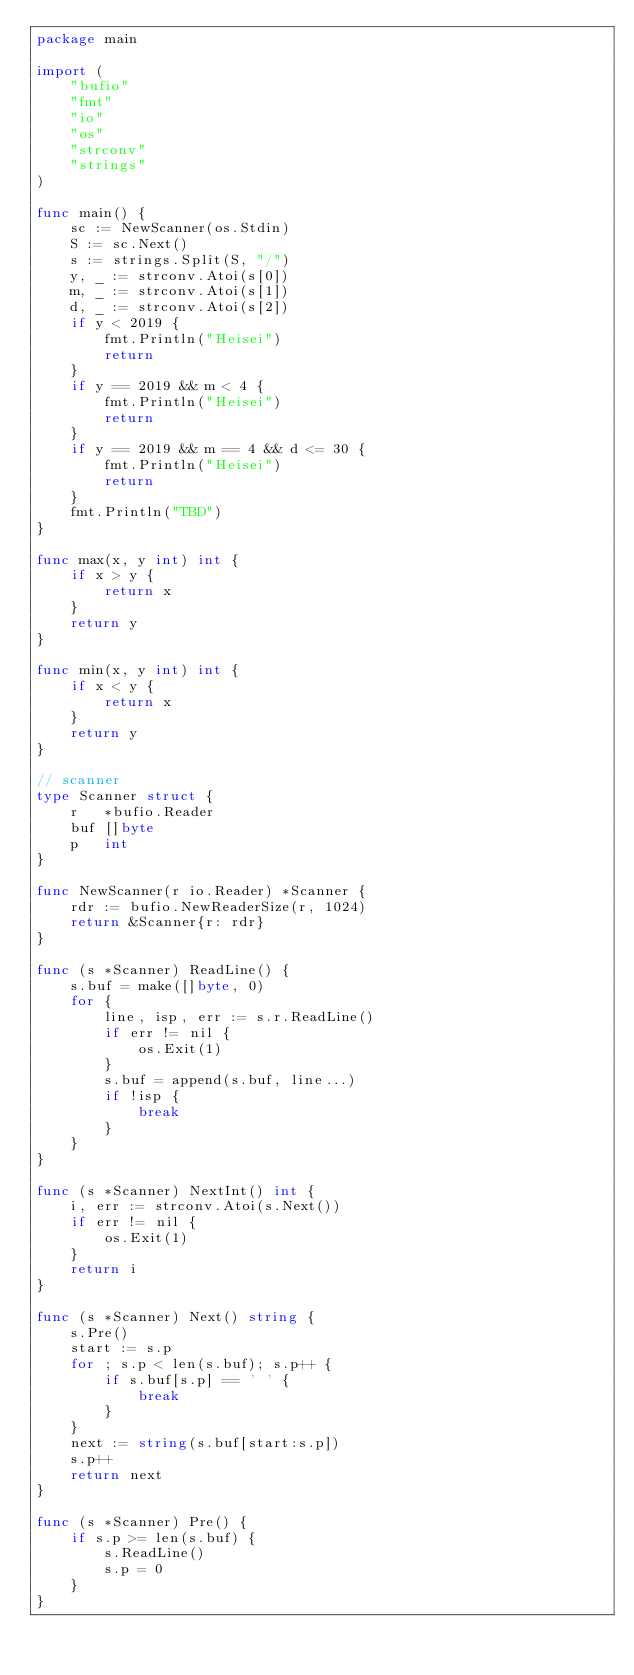Convert code to text. <code><loc_0><loc_0><loc_500><loc_500><_Go_>package main

import (
	"bufio"
	"fmt"
	"io"
	"os"
	"strconv"
	"strings"
)

func main() {
	sc := NewScanner(os.Stdin)
	S := sc.Next()
	s := strings.Split(S, "/")
	y, _ := strconv.Atoi(s[0])
	m, _ := strconv.Atoi(s[1])
	d, _ := strconv.Atoi(s[2])
	if y < 2019 {
		fmt.Println("Heisei")
		return
	}
	if y == 2019 && m < 4 {
		fmt.Println("Heisei")
		return
	}
	if y == 2019 && m == 4 && d <= 30 {
		fmt.Println("Heisei")
		return
	}
	fmt.Println("TBD")
}

func max(x, y int) int {
	if x > y {
		return x
	}
	return y
}

func min(x, y int) int {
	if x < y {
		return x
	}
	return y
}

// scanner
type Scanner struct {
	r   *bufio.Reader
	buf []byte
	p   int
}

func NewScanner(r io.Reader) *Scanner {
	rdr := bufio.NewReaderSize(r, 1024)
	return &Scanner{r: rdr}
}

func (s *Scanner) ReadLine() {
	s.buf = make([]byte, 0)
	for {
		line, isp, err := s.r.ReadLine()
		if err != nil {
			os.Exit(1)
		}
		s.buf = append(s.buf, line...)
		if !isp {
			break
		}
	}
}

func (s *Scanner) NextInt() int {
	i, err := strconv.Atoi(s.Next())
	if err != nil {
		os.Exit(1)
	}
	return i
}

func (s *Scanner) Next() string {
	s.Pre()
	start := s.p
	for ; s.p < len(s.buf); s.p++ {
		if s.buf[s.p] == ' ' {
			break
		}
	}
	next := string(s.buf[start:s.p])
	s.p++
	return next
}

func (s *Scanner) Pre() {
	if s.p >= len(s.buf) {
		s.ReadLine()
		s.p = 0
	}
}
</code> 